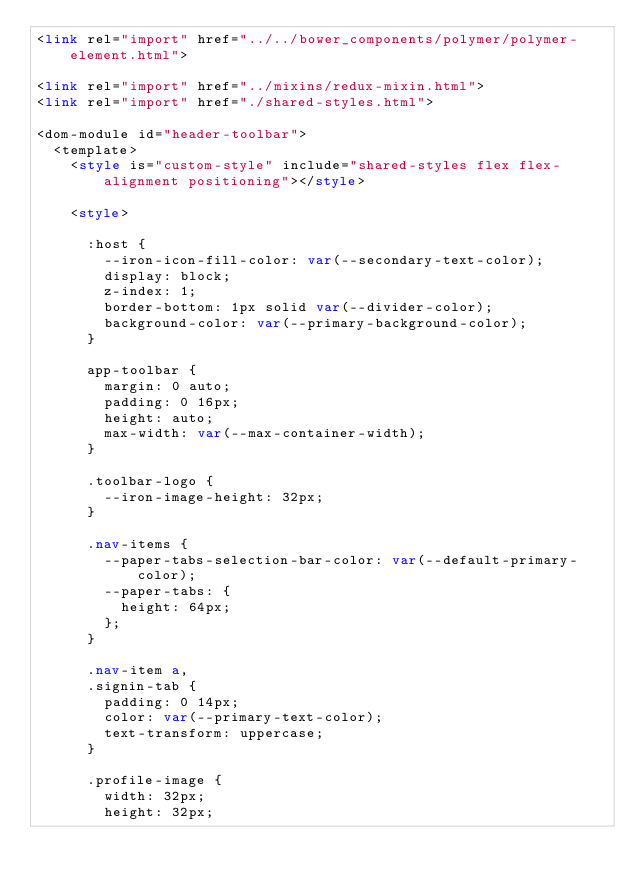Convert code to text. <code><loc_0><loc_0><loc_500><loc_500><_HTML_><link rel="import" href="../../bower_components/polymer/polymer-element.html">

<link rel="import" href="../mixins/redux-mixin.html">
<link rel="import" href="./shared-styles.html">

<dom-module id="header-toolbar">
  <template>
    <style is="custom-style" include="shared-styles flex flex-alignment positioning"></style>

    <style>

      :host {
        --iron-icon-fill-color: var(--secondary-text-color);
        display: block;
        z-index: 1;
        border-bottom: 1px solid var(--divider-color);
        background-color: var(--primary-background-color);
      }

      app-toolbar {
        margin: 0 auto;
        padding: 0 16px;
        height: auto;
        max-width: var(--max-container-width);
      }

      .toolbar-logo {
        --iron-image-height: 32px;
      }

      .nav-items {
        --paper-tabs-selection-bar-color: var(--default-primary-color);
        --paper-tabs: {
          height: 64px;
        };
      }

      .nav-item a,
      .signin-tab {
        padding: 0 14px;
        color: var(--primary-text-color);
        text-transform: uppercase;
      }

      .profile-image {
        width: 32px;
        height: 32px;</code> 